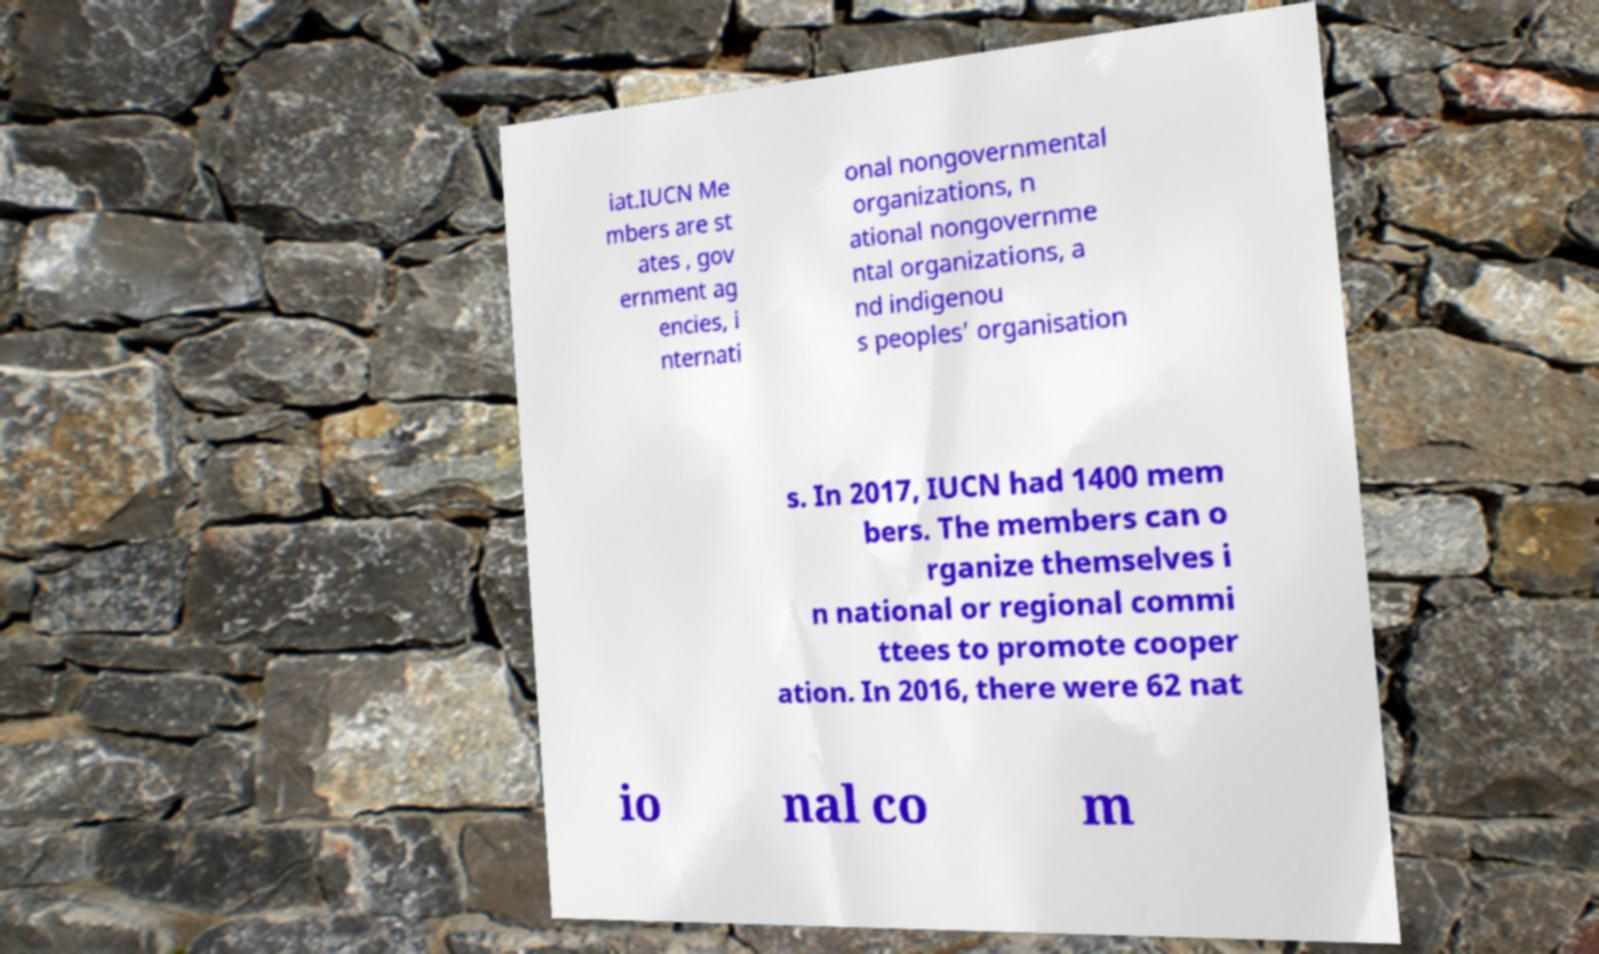For documentation purposes, I need the text within this image transcribed. Could you provide that? iat.IUCN Me mbers are st ates , gov ernment ag encies, i nternati onal nongovernmental organizations, n ational nongovernme ntal organizations, a nd indigenou s peoples’ organisation s. In 2017, IUCN had 1400 mem bers. The members can o rganize themselves i n national or regional commi ttees to promote cooper ation. In 2016, there were 62 nat io nal co m 